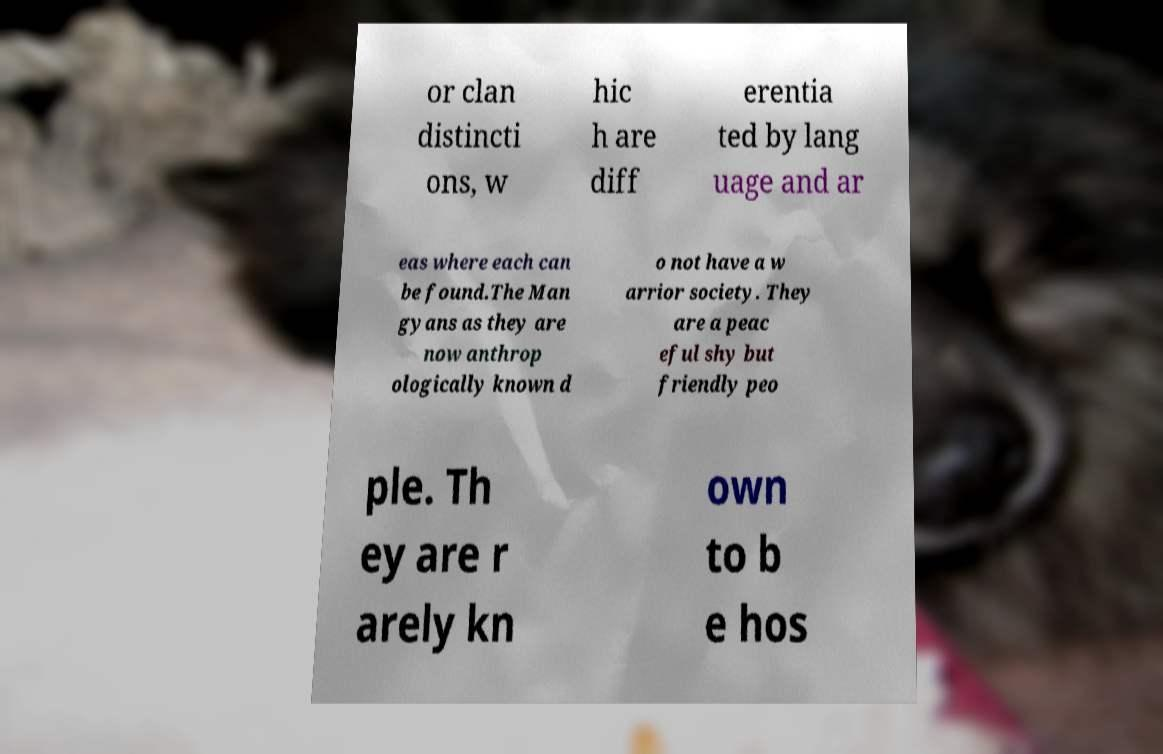I need the written content from this picture converted into text. Can you do that? or clan distincti ons, w hic h are diff erentia ted by lang uage and ar eas where each can be found.The Man gyans as they are now anthrop ologically known d o not have a w arrior society. They are a peac eful shy but friendly peo ple. Th ey are r arely kn own to b e hos 